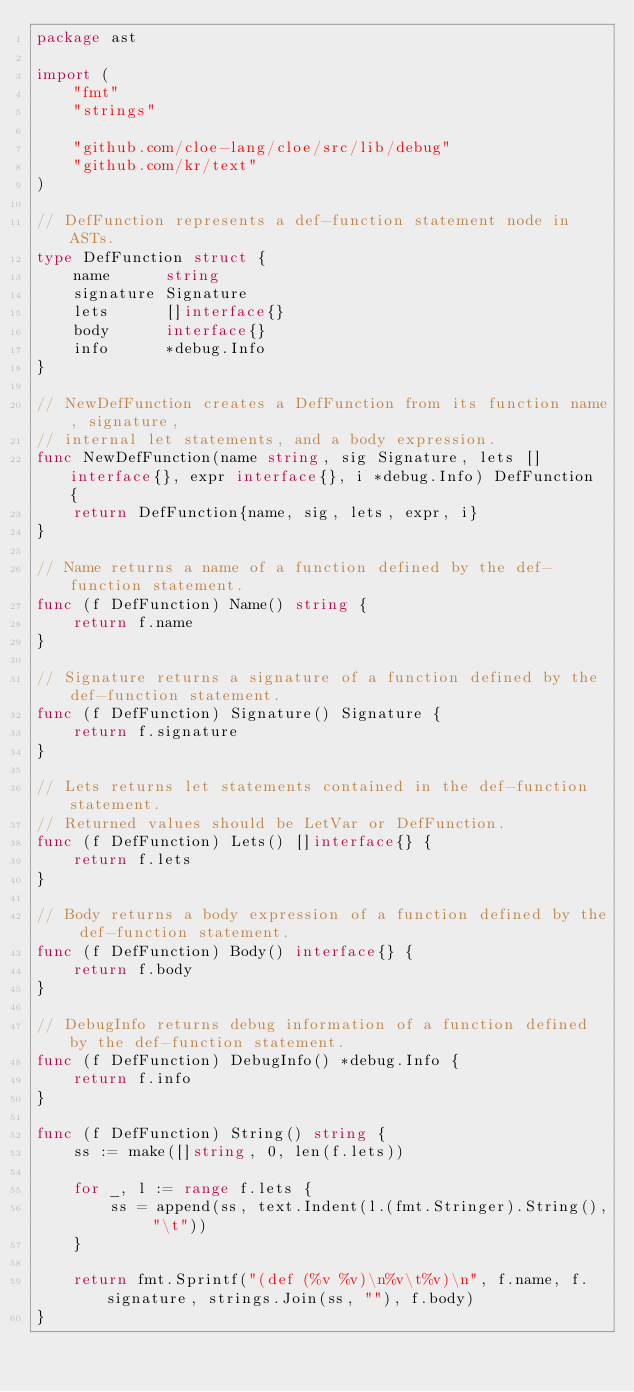Convert code to text. <code><loc_0><loc_0><loc_500><loc_500><_Go_>package ast

import (
	"fmt"
	"strings"

	"github.com/cloe-lang/cloe/src/lib/debug"
	"github.com/kr/text"
)

// DefFunction represents a def-function statement node in ASTs.
type DefFunction struct {
	name      string
	signature Signature
	lets      []interface{}
	body      interface{}
	info      *debug.Info
}

// NewDefFunction creates a DefFunction from its function name, signature,
// internal let statements, and a body expression.
func NewDefFunction(name string, sig Signature, lets []interface{}, expr interface{}, i *debug.Info) DefFunction {
	return DefFunction{name, sig, lets, expr, i}
}

// Name returns a name of a function defined by the def-function statement.
func (f DefFunction) Name() string {
	return f.name
}

// Signature returns a signature of a function defined by the def-function statement.
func (f DefFunction) Signature() Signature {
	return f.signature
}

// Lets returns let statements contained in the def-function statement.
// Returned values should be LetVar or DefFunction.
func (f DefFunction) Lets() []interface{} {
	return f.lets
}

// Body returns a body expression of a function defined by the def-function statement.
func (f DefFunction) Body() interface{} {
	return f.body
}

// DebugInfo returns debug information of a function defined by the def-function statement.
func (f DefFunction) DebugInfo() *debug.Info {
	return f.info
}

func (f DefFunction) String() string {
	ss := make([]string, 0, len(f.lets))

	for _, l := range f.lets {
		ss = append(ss, text.Indent(l.(fmt.Stringer).String(), "\t"))
	}

	return fmt.Sprintf("(def (%v %v)\n%v\t%v)\n", f.name, f.signature, strings.Join(ss, ""), f.body)
}
</code> 